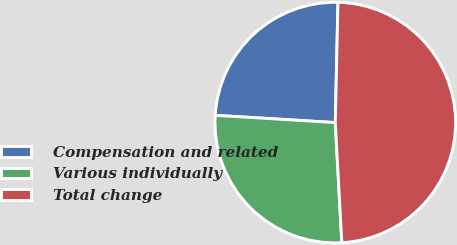<chart> <loc_0><loc_0><loc_500><loc_500><pie_chart><fcel>Compensation and related<fcel>Various individually<fcel>Total change<nl><fcel>24.39%<fcel>26.83%<fcel>48.78%<nl></chart> 